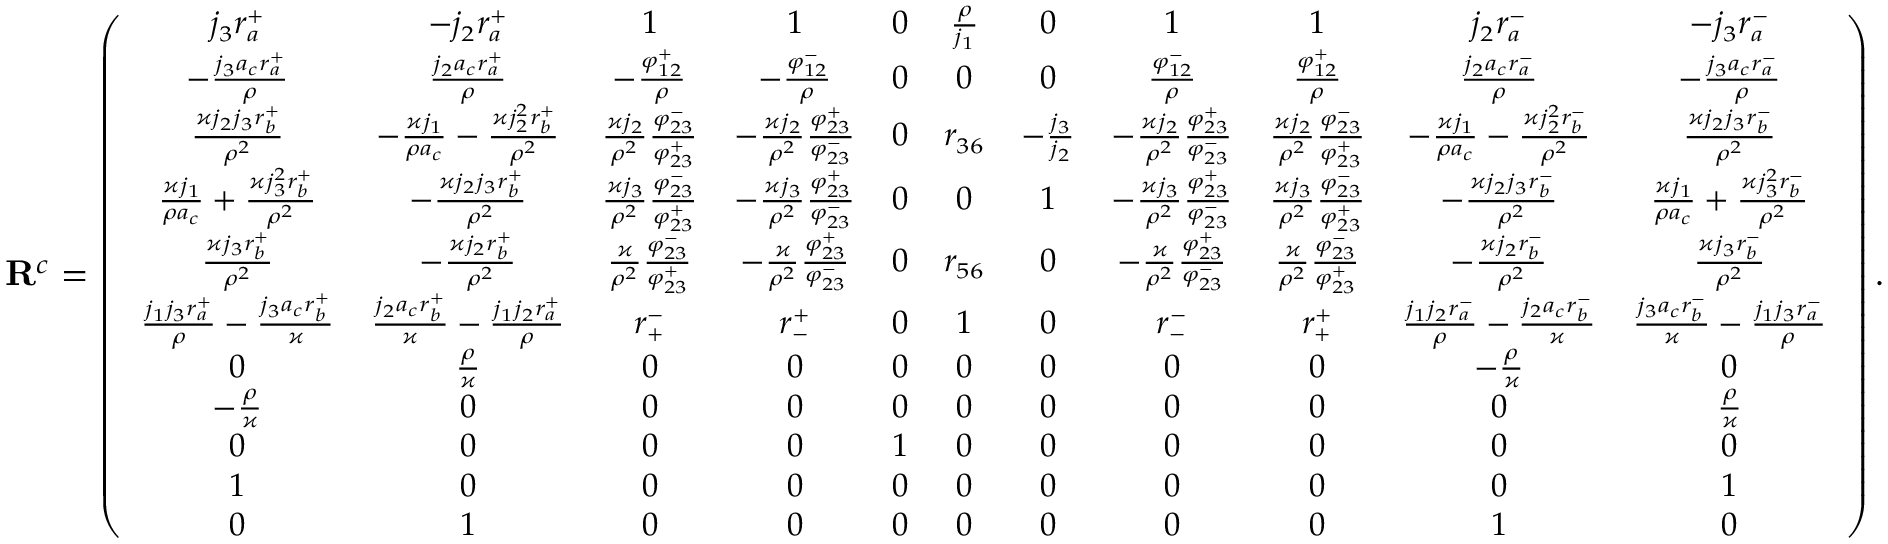Convert formula to latex. <formula><loc_0><loc_0><loc_500><loc_500>R ^ { c } = \left ( \begin{array} { c c c c c c c c c c c } { j _ { 3 } r _ { a } ^ { + } } & { - j _ { 2 } r _ { a } ^ { + } } & { 1 } & { 1 } & { 0 } & { \frac { \rho } { j _ { 1 } } } & { 0 } & { 1 } & { 1 } & { j _ { 2 } r _ { a } ^ { - } } & { - j _ { 3 } r _ { a } ^ { - } } \\ { - \frac { j _ { 3 } a _ { c } r _ { a } ^ { + } } { \rho } } & { \frac { j _ { 2 } a _ { c } r _ { a } ^ { + } } { \rho } } & { - \frac { \varphi _ { 1 2 } ^ { + } } { \rho } } & { - \frac { \varphi _ { 1 2 } ^ { - } } { \rho } } & { 0 } & { 0 } & { 0 } & { \frac { \varphi _ { 1 2 } ^ { - } } { \rho } } & { \frac { \varphi _ { 1 2 } ^ { + } } { \rho } } & { \frac { j _ { 2 } a _ { c } r _ { a } ^ { - } } { \rho } } & { - \frac { j _ { 3 } a _ { c } r _ { a } ^ { - } } { \rho } } \\ { \frac { \varkappa j _ { 2 } j _ { 3 } r _ { b } ^ { + } } { \rho ^ { 2 } } } & { - \frac { \varkappa j _ { 1 } } { \rho a _ { c } } - \frac { \varkappa j _ { 2 } ^ { 2 } r _ { b } ^ { + } } { \rho ^ { 2 } } } & { \frac { \varkappa j _ { 2 } } { \rho ^ { 2 } } \frac { \varphi _ { 2 3 } ^ { - } } { \varphi _ { 2 3 } ^ { + } } } & { - \frac { \varkappa j _ { 2 } } { \rho ^ { 2 } } \frac { \varphi _ { 2 3 } ^ { + } } { \varphi _ { 2 3 } ^ { - } } } & { 0 } & { r _ { 3 6 } } & { - \frac { j _ { 3 } } { j _ { 2 } } } & { - \frac { \varkappa j _ { 2 } } { \rho ^ { 2 } } \frac { \varphi _ { 2 3 } ^ { + } } { \varphi _ { 2 3 } ^ { - } } } & { \frac { \varkappa j _ { 2 } } { \rho ^ { 2 } } \frac { \varphi _ { 2 3 } ^ { - } } { \varphi _ { 2 3 } ^ { + } } } & { - \frac { \varkappa j _ { 1 } } { \rho a _ { c } } - \frac { \varkappa j _ { 2 } ^ { 2 } r _ { b } ^ { - } } { \rho ^ { 2 } } } & { \frac { \varkappa j _ { 2 } j _ { 3 } r _ { b } ^ { - } } { \rho ^ { 2 } } } \\ { \frac { \varkappa j _ { 1 } } { \rho a _ { c } } + \frac { \varkappa j _ { 3 } ^ { 2 } r _ { b } ^ { + } } { \rho ^ { 2 } } } & { - \frac { \varkappa j _ { 2 } j _ { 3 } r _ { b } ^ { + } } { \rho ^ { 2 } } } & { \frac { \varkappa j _ { 3 } } { \rho ^ { 2 } } \frac { \varphi _ { 2 3 } ^ { - } } { \varphi _ { 2 3 } ^ { + } } } & { - \frac { \varkappa j _ { 3 } } { \rho ^ { 2 } } \frac { \varphi _ { 2 3 } ^ { + } } { \varphi _ { 2 3 } ^ { - } } } & { 0 } & { 0 } & { 1 } & { - \frac { \varkappa j _ { 3 } } { \rho ^ { 2 } } \frac { \varphi _ { 2 3 } ^ { + } } { \varphi _ { 2 3 } ^ { - } } } & { \frac { \varkappa j _ { 3 } } { \rho ^ { 2 } } \frac { \varphi _ { 2 3 } ^ { - } } { \varphi _ { 2 3 } ^ { + } } } & { - \frac { \varkappa j _ { 2 } j _ { 3 } r _ { b } ^ { - } } { \rho ^ { 2 } } } & { \frac { \varkappa j _ { 1 } } { \rho a _ { c } } + \frac { \varkappa j _ { 3 } ^ { 2 } r _ { b } ^ { - } } { \rho ^ { 2 } } } \\ { \frac { \varkappa j _ { 3 } r _ { b } ^ { + } } { \rho ^ { 2 } } } & { - \frac { \varkappa j _ { 2 } r _ { b } ^ { + } } { \rho ^ { 2 } } } & { \frac { \varkappa } { \rho ^ { 2 } } \frac { \varphi _ { 2 3 } ^ { - } } { \varphi _ { 2 3 } ^ { + } } } & { - \frac { \varkappa } { \rho ^ { 2 } } \frac { \varphi _ { 2 3 } ^ { + } } { \varphi _ { 2 3 } ^ { - } } } & { 0 } & { r _ { 5 6 } } & { 0 } & { - \frac { \varkappa } { \rho ^ { 2 } } \frac { \varphi _ { 2 3 } ^ { + } } { \varphi _ { 2 3 } ^ { - } } } & { \frac { \varkappa } { \rho ^ { 2 } } \frac { \varphi _ { 2 3 } ^ { - } } { \varphi _ { 2 3 } ^ { + } } } & { - \frac { \varkappa j _ { 2 } r _ { b } ^ { - } } { \rho ^ { 2 } } } & { \frac { \varkappa j _ { 3 } r _ { b } ^ { - } } { \rho ^ { 2 } } } \\ { \frac { j _ { 1 } j _ { 3 } r _ { a } ^ { + } } { \rho } - \frac { j _ { 3 } a _ { c } r _ { b } ^ { + } } { \varkappa } } & { \frac { j _ { 2 } a _ { c } r _ { b } ^ { + } } { \varkappa } - \frac { j _ { 1 } j _ { 2 } r _ { a } ^ { + } } { \rho } } & { r _ { + } ^ { - } } & { r _ { - } ^ { + } } & { 0 } & { 1 } & { 0 } & { r _ { - } ^ { - } } & { r _ { + } ^ { + } } & { \frac { j _ { 1 } j _ { 2 } r _ { a } ^ { - } } { \rho } - \frac { j _ { 2 } a _ { c } r _ { b } ^ { - } } { \varkappa } } & { \frac { j _ { 3 } a _ { c } r _ { b } ^ { - } } { \varkappa } - \frac { j _ { 1 } j _ { 3 } r _ { a } ^ { - } } { \rho } } \\ { 0 } & { \frac { \rho } { \varkappa } } & { 0 } & { 0 } & { 0 } & { 0 } & { 0 } & { 0 } & { 0 } & { - \frac { \rho } { \varkappa } } & { 0 } \\ { - \frac { \rho } { \varkappa } } & { 0 } & { 0 } & { 0 } & { 0 } & { 0 } & { 0 } & { 0 } & { 0 } & { 0 } & { \frac { \rho } { \varkappa } } \\ { 0 } & { 0 } & { 0 } & { 0 } & { 1 } & { 0 } & { 0 } & { 0 } & { 0 } & { 0 } & { 0 } \\ { 1 } & { 0 } & { 0 } & { 0 } & { 0 } & { 0 } & { 0 } & { 0 } & { 0 } & { 0 } & { 1 } \\ { 0 } & { 1 } & { 0 } & { 0 } & { 0 } & { 0 } & { 0 } & { 0 } & { 0 } & { 1 } & { 0 } \end{array} \right ) .</formula> 